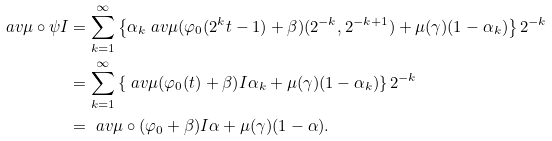<formula> <loc_0><loc_0><loc_500><loc_500>\ a v { \mu \circ \psi } I & = \sum _ { k = 1 } ^ { \infty } \left \{ \alpha _ { k } \ a v { \mu ( \varphi _ { 0 } ( 2 ^ { k } t - 1 ) + \beta ) } { ( 2 ^ { - k } , 2 ^ { - k + 1 } ) } + \mu ( \gamma ) ( 1 - \alpha _ { k } ) \right \} 2 ^ { - k } \\ & = \sum _ { k = 1 } ^ { \infty } \left \{ \ a v { \mu ( \varphi _ { 0 } ( t ) + \beta ) } I \alpha _ { k } + \mu ( \gamma ) ( 1 - \alpha _ { k } ) \right \} 2 ^ { - k } \\ & = \ a v { \mu \circ ( \varphi _ { 0 } + \beta ) } I \alpha + \mu ( \gamma ) ( 1 - \alpha ) .</formula> 